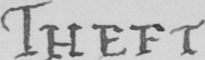What text is written in this handwritten line? THEFT . 